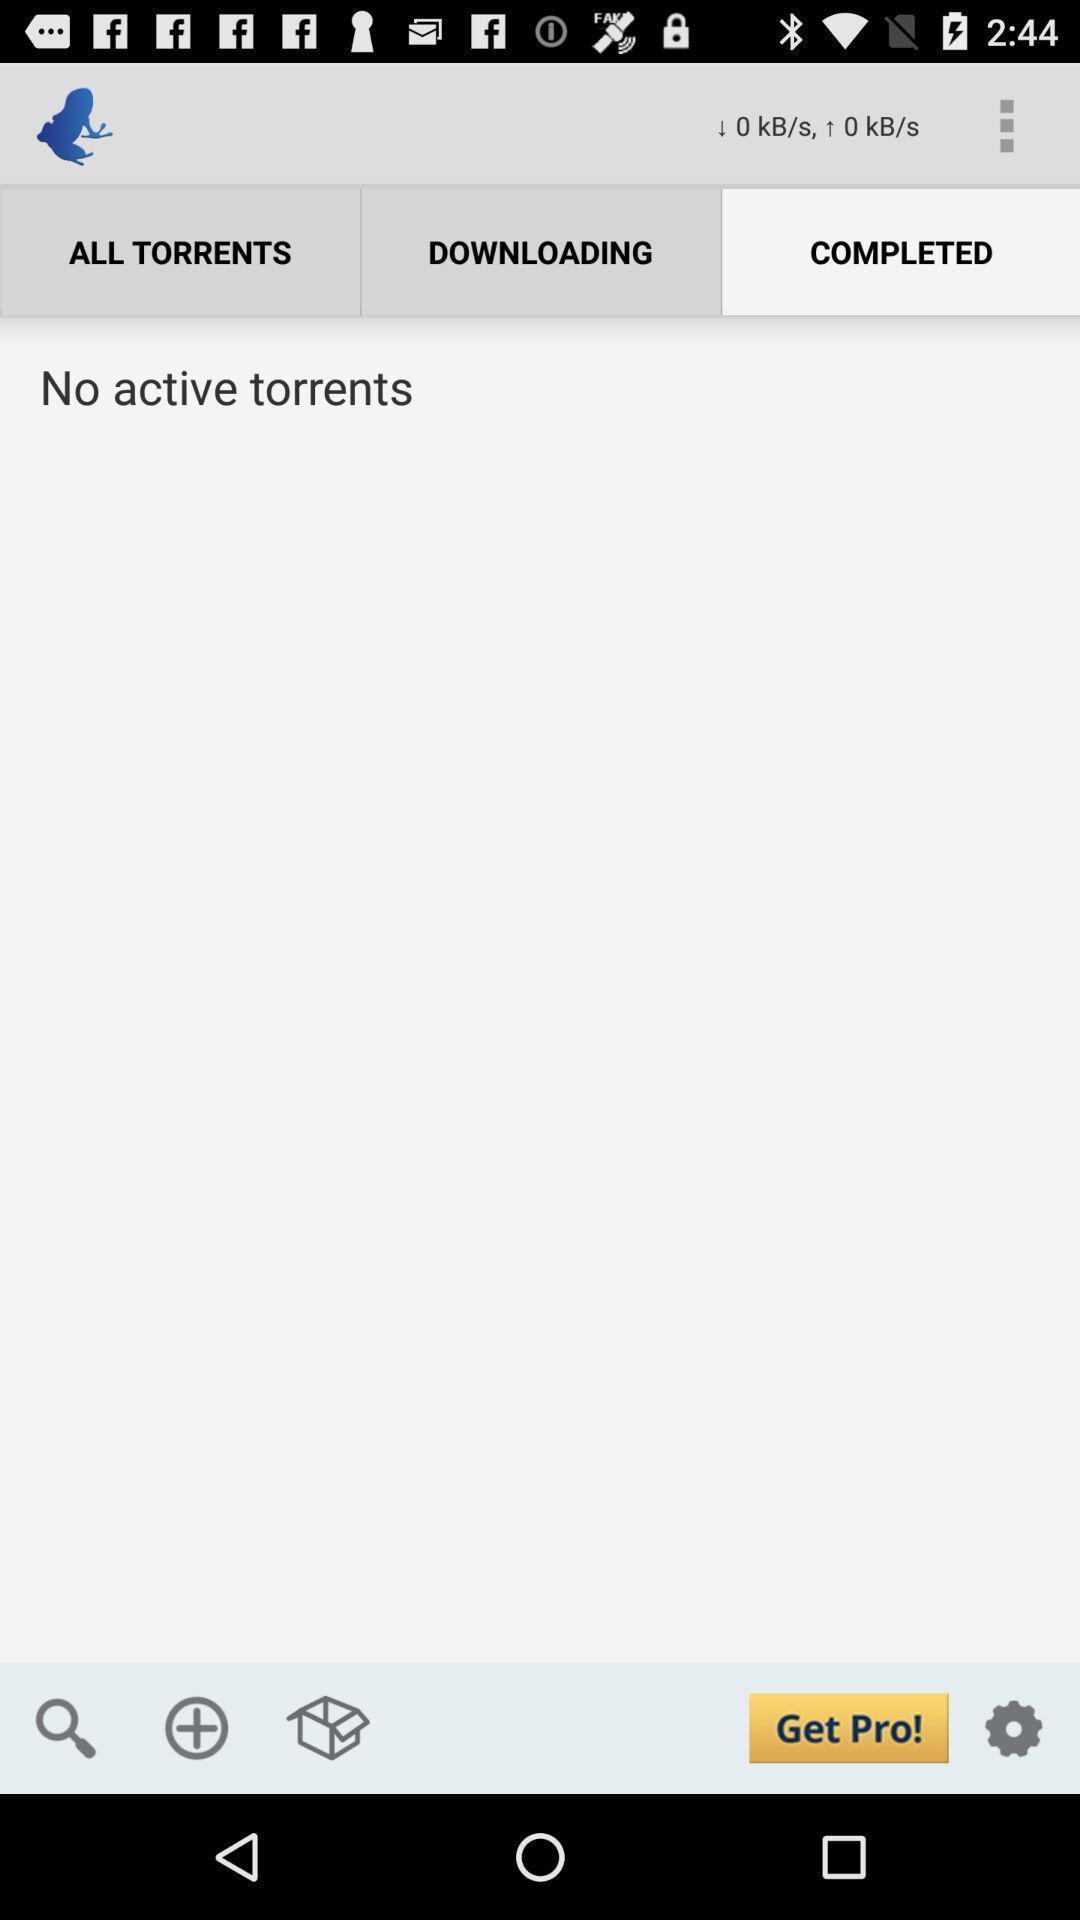Provide a textual representation of this image. Page showing multiple options on an app. 